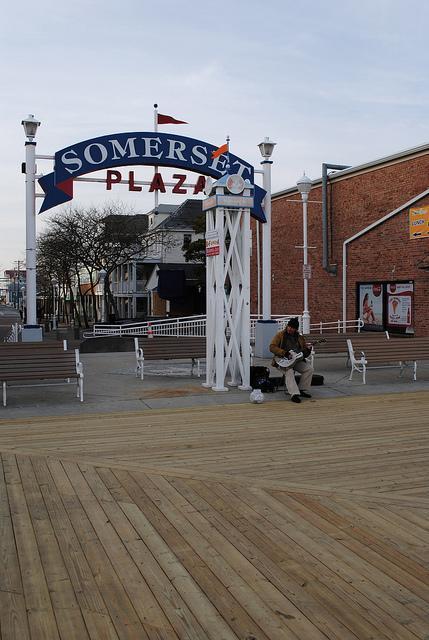How many benches are there?
Give a very brief answer. 2. How many oranges can you see?
Give a very brief answer. 0. 